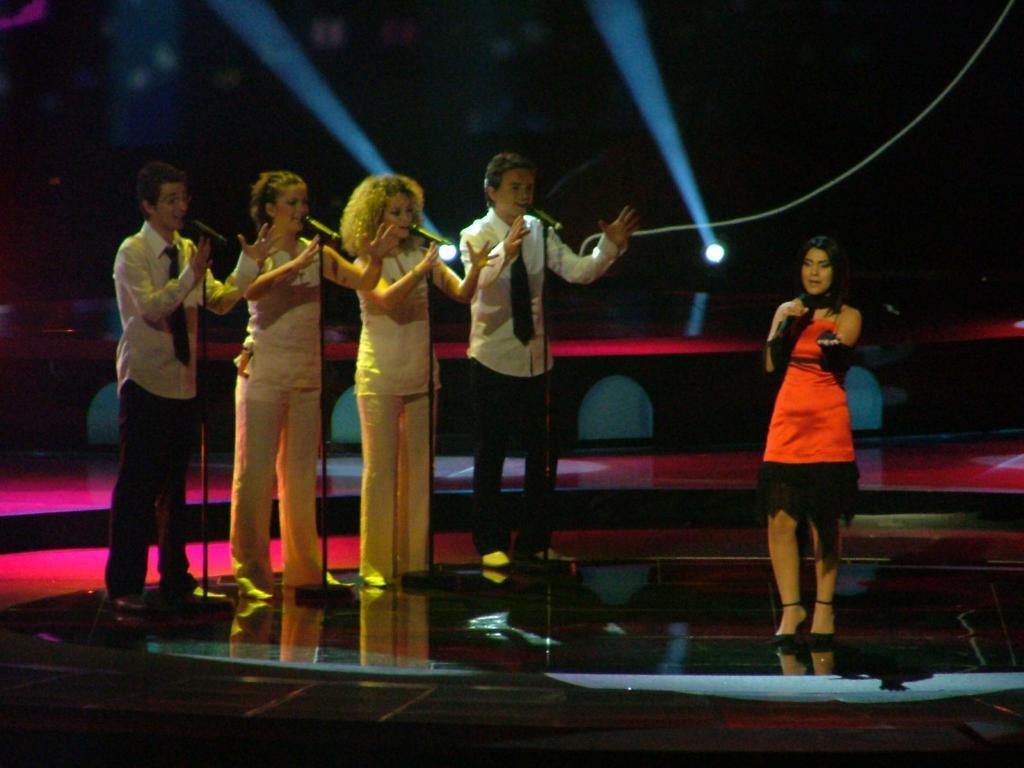Can you describe this image briefly? In this image we can see a group of people standing on the ground. One woman is holding a microphone in her hand. In the background, we can see a group of microphones on stands and some lights. 